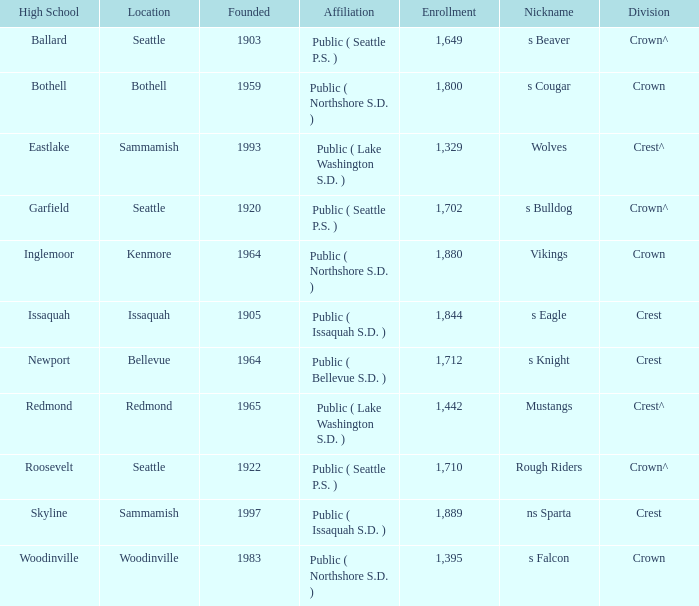What is the affiliation of a location called Issaquah? Public ( Issaquah S.D. ). 